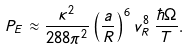<formula> <loc_0><loc_0><loc_500><loc_500>P _ { E } \approx \frac { \kappa ^ { 2 } } { 2 8 8 \pi ^ { 2 } } \left ( \frac { a } { R } \right ) ^ { 6 } v _ { R } ^ { 8 } \, \frac { \hbar { \Omega } } { T } .</formula> 